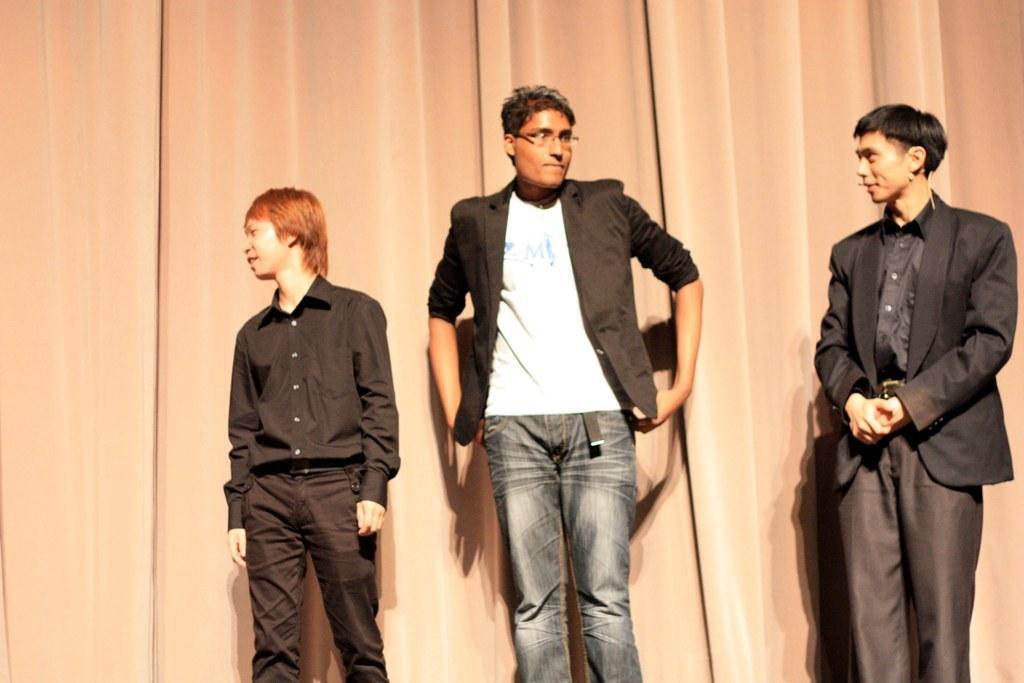Could you give a brief overview of what you see in this image? In this image there are three men standing. To the right there is a man standing. He is wearing a microphone around his ear. Behind them there is a curtain. 